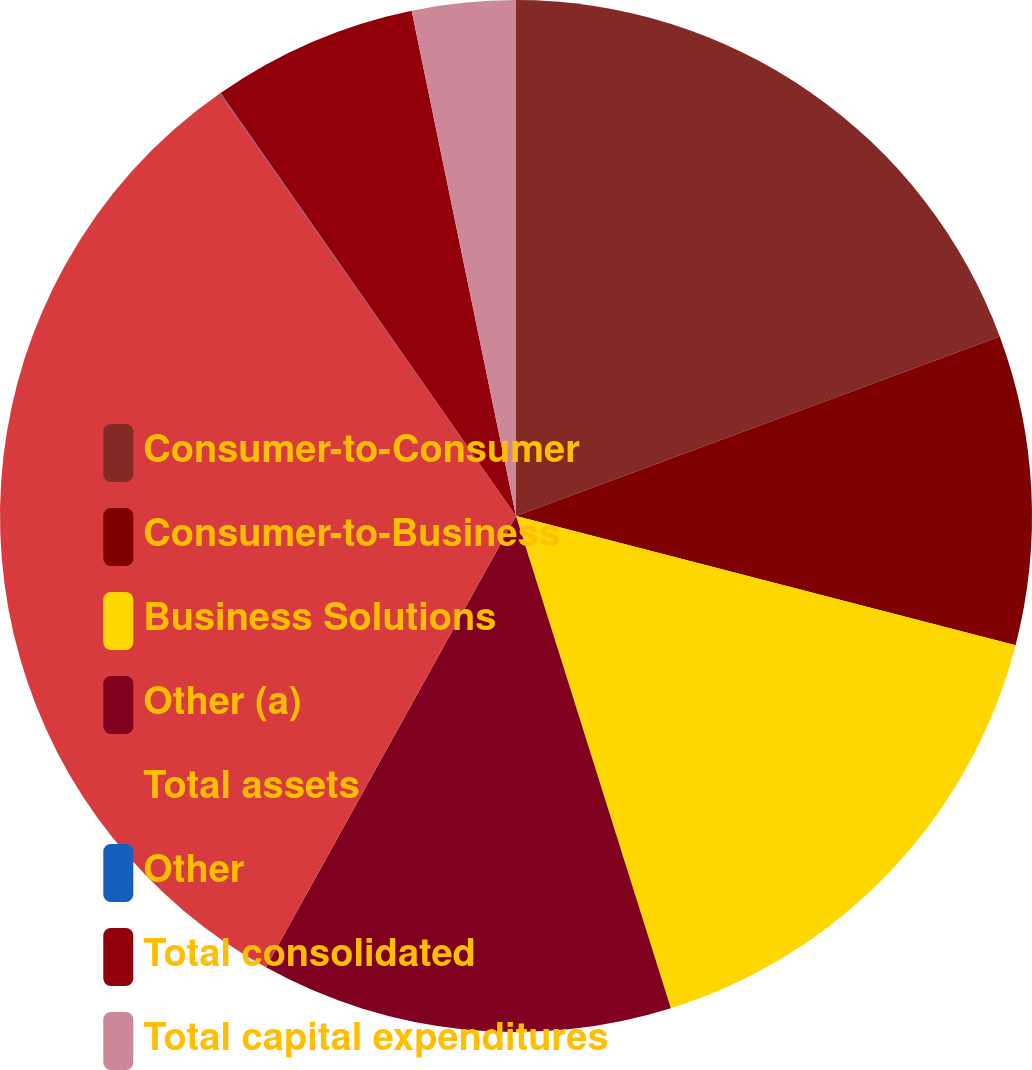Convert chart to OTSL. <chart><loc_0><loc_0><loc_500><loc_500><pie_chart><fcel>Consumer-to-Consumer<fcel>Consumer-to-Business<fcel>Business Solutions<fcel>Other (a)<fcel>Total assets<fcel>Other<fcel>Total consolidated<fcel>Total capital expenditures<nl><fcel>19.34%<fcel>9.68%<fcel>16.12%<fcel>12.9%<fcel>32.22%<fcel>0.02%<fcel>6.46%<fcel>3.24%<nl></chart> 